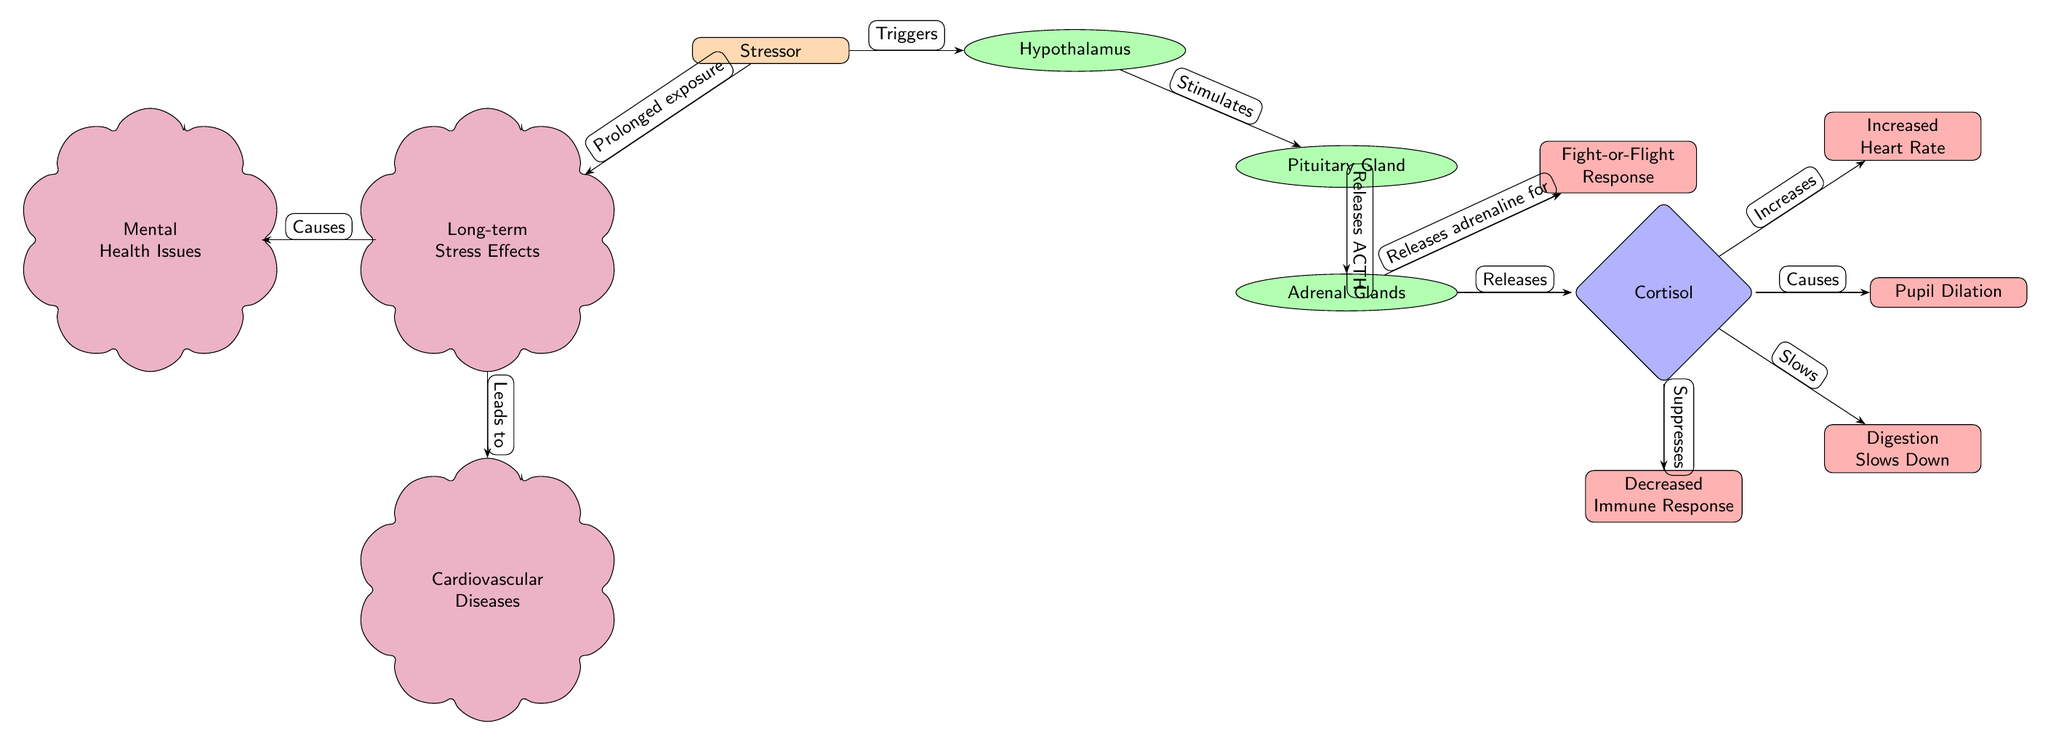What triggers the hypothalamus? The diagram shows that the "Stressor" node is the source that connects to and triggers the "Hypothalamus" node, indicating that the hypothalamus is activated by a stressor.
Answer: Stressor How many effects does cortisol have? By counting the outward arrows from the "Cortisol" node, we can see that it has four effects: Increased Heart Rate, Pupil Dilation, Digestion Slows Down, and Decreased Immune Response.
Answer: 4 What is released by the adrenal glands? The diagram indicates that the adrenal glands release both "Cortisol" and adrenaline, as seen in the connections stemming from the "Adrenal Glands" node.
Answer: Cortisol and adrenaline What relationship exists between long-term stress and mental health? The diagram shows that "Long-term Stress Effects" leads to "Mental Health Issues," establishing a causal relationship between the two nodes.
Answer: Causes Which organ is stimulated by the hypothalamus? The diagram illustrates that the "Pituitary Gland" is the node that is stimulated directly by the "Hypothalamus," showing a clear connection.
Answer: Pituitary Gland What is the consequence of long-term stress? The diagram connects "Long-term Stress Effects" to "Cardiovascular Diseases," indicating that long-term stress leads to this consequence as one of the outcomes.
Answer: Cardiovascular Diseases What is the primary response indicated for stress? According to the diagram, the "Fight-or-Flight Response" is a primary response associated with the adrenal glands when they release adrenaline.
Answer: Fight-or-Flight Response Which node experiences decreased function due to cortisol? The diagram specifies that cortisol has a suppressive effect on the "Immune Response," indicating a decrease in the immune system's functionality.
Answer: Immune Response 